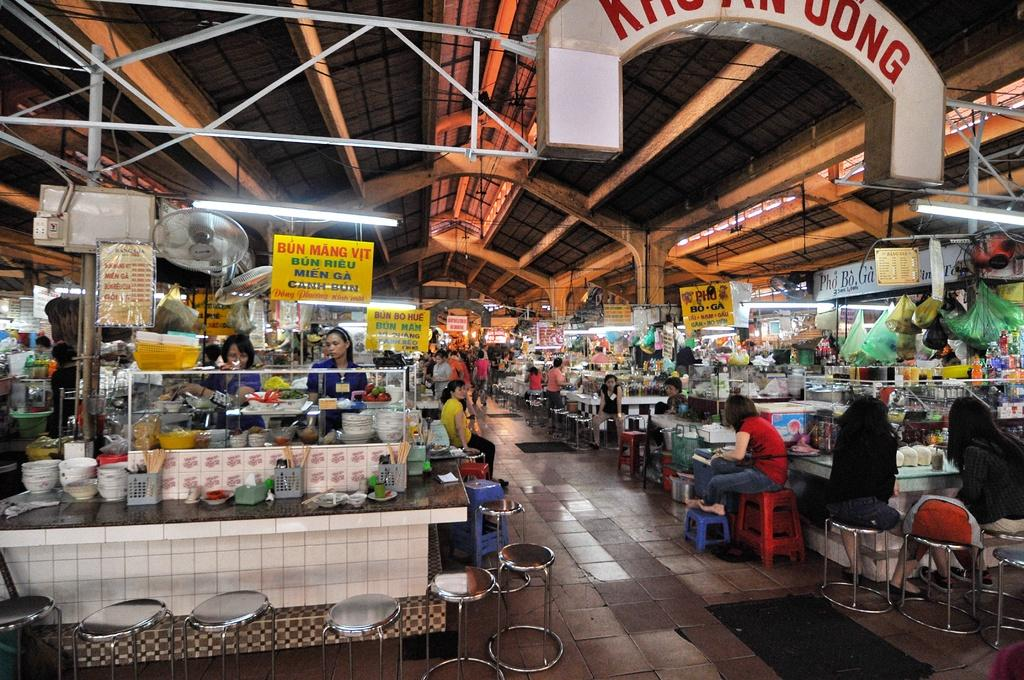<image>
Offer a succinct explanation of the picture presented. A busy large open room with multiple counters and stools selling various types of Mein Ga 